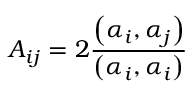<formula> <loc_0><loc_0><loc_500><loc_500>A _ { i j } = 2 { \frac { \left ( \alpha _ { i } , \alpha _ { j } \right ) } { \left ( \alpha _ { i } , \alpha _ { i } \right ) } }</formula> 